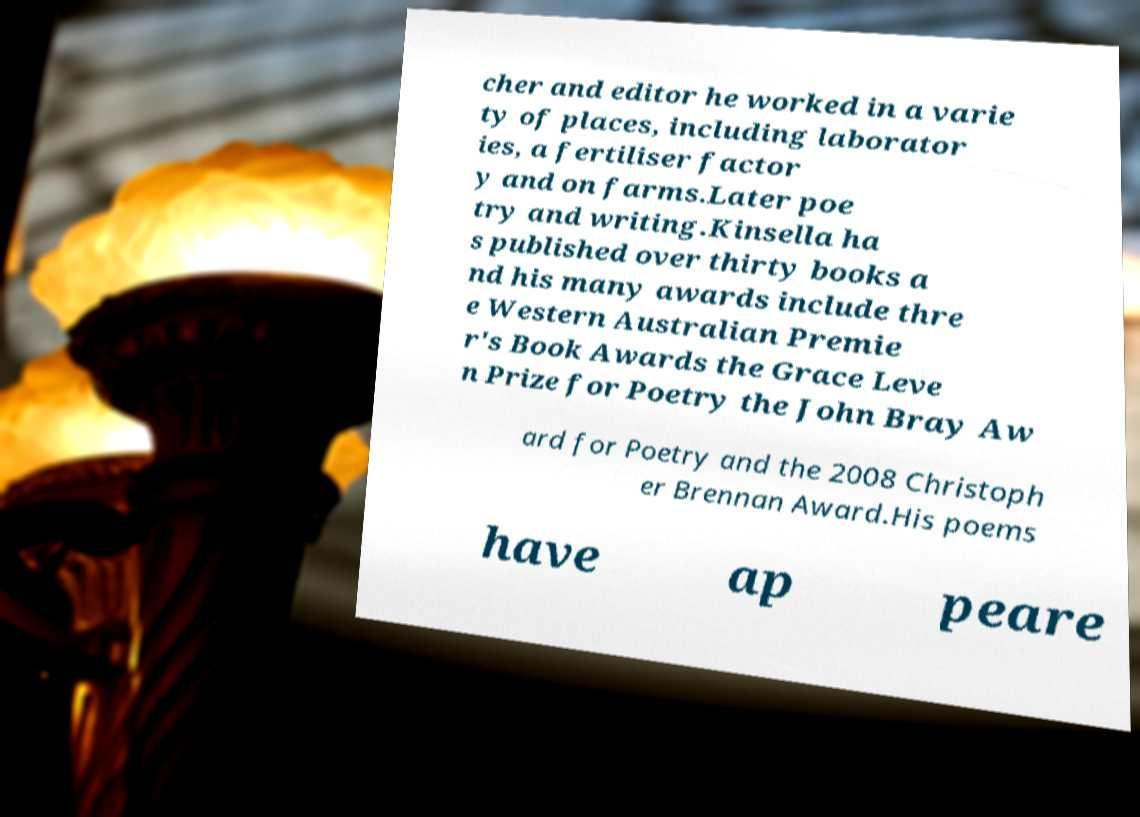Could you assist in decoding the text presented in this image and type it out clearly? cher and editor he worked in a varie ty of places, including laborator ies, a fertiliser factor y and on farms.Later poe try and writing.Kinsella ha s published over thirty books a nd his many awards include thre e Western Australian Premie r's Book Awards the Grace Leve n Prize for Poetry the John Bray Aw ard for Poetry and the 2008 Christoph er Brennan Award.His poems have ap peare 